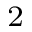<formula> <loc_0><loc_0><loc_500><loc_500>^ { 2 }</formula> 